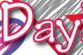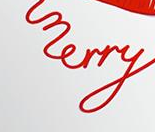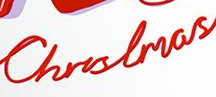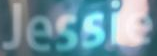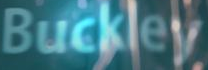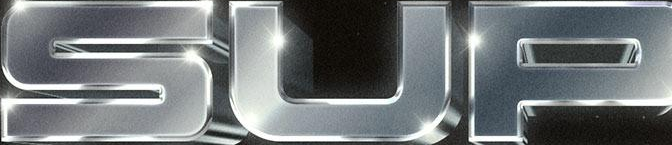Transcribe the words shown in these images in order, separated by a semicolon. Day; merry; Christmas; Jessie; Buckley; SUP 